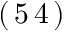Convert formula to latex. <formula><loc_0><loc_0><loc_500><loc_500>( \, 5 \, 4 \, )</formula> 